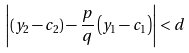Convert formula to latex. <formula><loc_0><loc_0><loc_500><loc_500>\left | ( y _ { 2 } - c _ { 2 } ) - \frac { p } { q } \left ( y _ { 1 } - c _ { 1 } \right ) \right | < d</formula> 